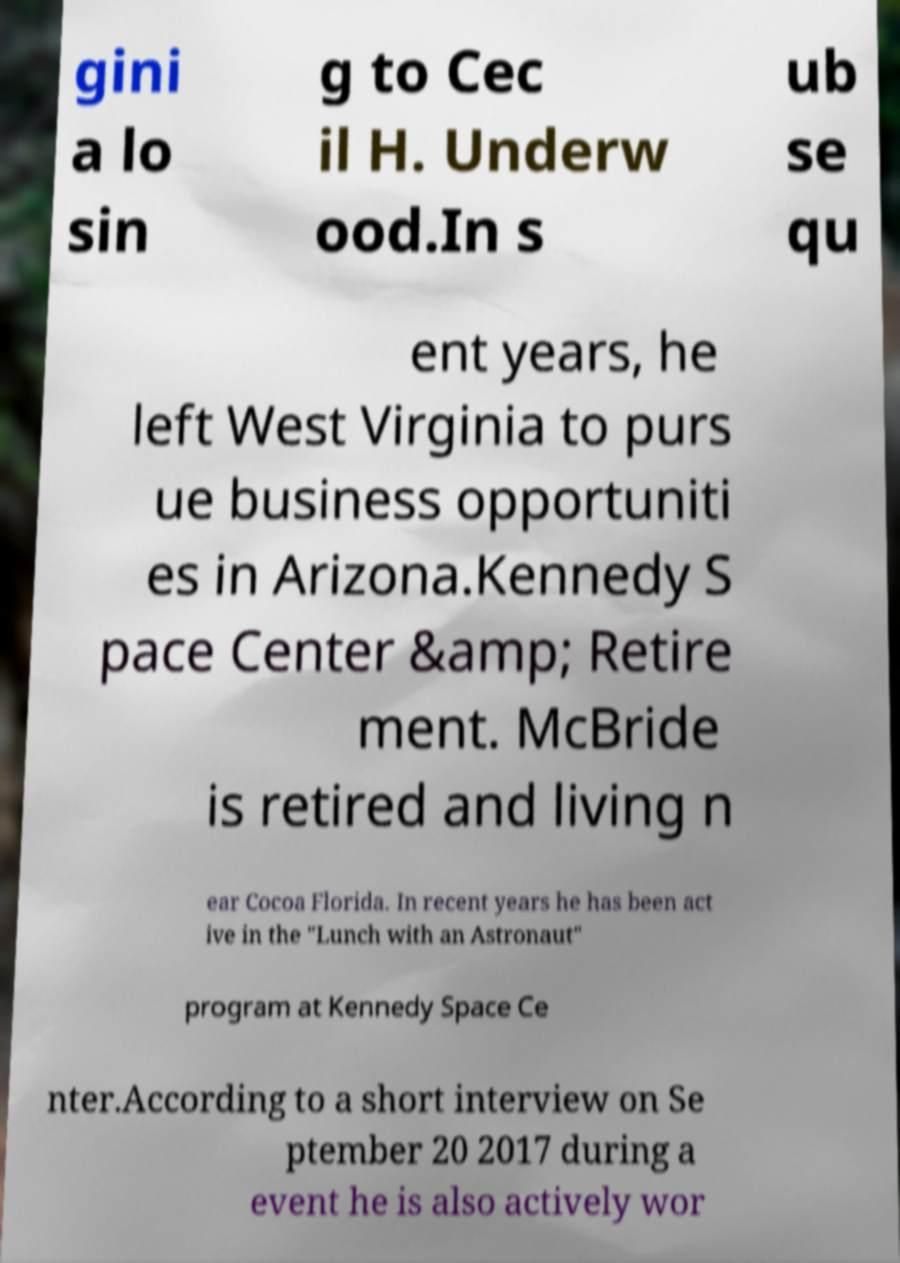What messages or text are displayed in this image? I need them in a readable, typed format. gini a lo sin g to Cec il H. Underw ood.In s ub se qu ent years, he left West Virginia to purs ue business opportuniti es in Arizona.Kennedy S pace Center &amp; Retire ment. McBride is retired and living n ear Cocoa Florida. In recent years he has been act ive in the "Lunch with an Astronaut" program at Kennedy Space Ce nter.According to a short interview on Se ptember 20 2017 during a event he is also actively wor 